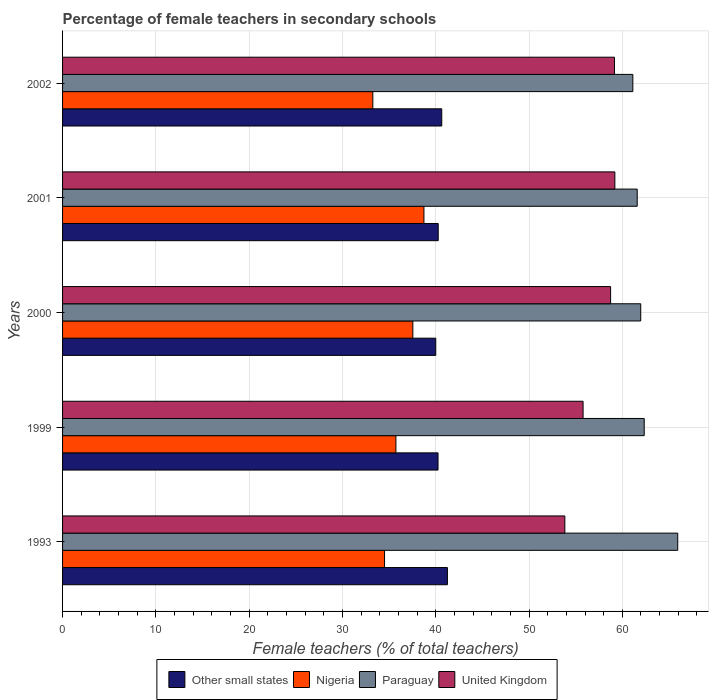How many groups of bars are there?
Keep it short and to the point. 5. Are the number of bars per tick equal to the number of legend labels?
Your answer should be compact. Yes. Are the number of bars on each tick of the Y-axis equal?
Provide a succinct answer. Yes. In how many cases, is the number of bars for a given year not equal to the number of legend labels?
Ensure brevity in your answer.  0. What is the percentage of female teachers in Other small states in 2001?
Give a very brief answer. 40.27. Across all years, what is the maximum percentage of female teachers in Other small states?
Your answer should be compact. 41.25. Across all years, what is the minimum percentage of female teachers in Paraguay?
Offer a terse response. 61.13. In which year was the percentage of female teachers in United Kingdom maximum?
Your answer should be very brief. 2001. What is the total percentage of female teachers in United Kingdom in the graph?
Offer a very short reply. 286.74. What is the difference between the percentage of female teachers in Nigeria in 1993 and that in 2000?
Keep it short and to the point. -3.03. What is the difference between the percentage of female teachers in United Kingdom in 1999 and the percentage of female teachers in Other small states in 2001?
Keep it short and to the point. 15.53. What is the average percentage of female teachers in Other small states per year?
Offer a terse response. 40.48. In the year 1999, what is the difference between the percentage of female teachers in Nigeria and percentage of female teachers in United Kingdom?
Your response must be concise. -20.06. What is the ratio of the percentage of female teachers in Nigeria in 1993 to that in 2002?
Keep it short and to the point. 1.04. What is the difference between the highest and the second highest percentage of female teachers in United Kingdom?
Make the answer very short. 0.04. What is the difference between the highest and the lowest percentage of female teachers in Other small states?
Your answer should be very brief. 1.25. In how many years, is the percentage of female teachers in Nigeria greater than the average percentage of female teachers in Nigeria taken over all years?
Keep it short and to the point. 2. Is the sum of the percentage of female teachers in United Kingdom in 1993 and 1999 greater than the maximum percentage of female teachers in Nigeria across all years?
Offer a very short reply. Yes. What does the 4th bar from the top in 1993 represents?
Keep it short and to the point. Other small states. What does the 3rd bar from the bottom in 1999 represents?
Provide a succinct answer. Paraguay. Is it the case that in every year, the sum of the percentage of female teachers in Nigeria and percentage of female teachers in Other small states is greater than the percentage of female teachers in Paraguay?
Make the answer very short. Yes. How many bars are there?
Give a very brief answer. 20. Are all the bars in the graph horizontal?
Provide a short and direct response. Yes. Are the values on the major ticks of X-axis written in scientific E-notation?
Make the answer very short. No. Does the graph contain any zero values?
Offer a terse response. No. Does the graph contain grids?
Provide a succinct answer. Yes. Where does the legend appear in the graph?
Provide a short and direct response. Bottom center. What is the title of the graph?
Your answer should be very brief. Percentage of female teachers in secondary schools. What is the label or title of the X-axis?
Your response must be concise. Female teachers (% of total teachers). What is the Female teachers (% of total teachers) in Other small states in 1993?
Your response must be concise. 41.25. What is the Female teachers (% of total teachers) of Nigeria in 1993?
Ensure brevity in your answer.  34.51. What is the Female teachers (% of total teachers) of Paraguay in 1993?
Offer a terse response. 65.94. What is the Female teachers (% of total teachers) of United Kingdom in 1993?
Give a very brief answer. 53.84. What is the Female teachers (% of total teachers) in Other small states in 1999?
Your response must be concise. 40.25. What is the Female teachers (% of total teachers) in Nigeria in 1999?
Your answer should be compact. 35.73. What is the Female teachers (% of total teachers) in Paraguay in 1999?
Make the answer very short. 62.35. What is the Female teachers (% of total teachers) in United Kingdom in 1999?
Provide a short and direct response. 55.79. What is the Female teachers (% of total teachers) in Other small states in 2000?
Your answer should be very brief. 40. What is the Female teachers (% of total teachers) of Nigeria in 2000?
Make the answer very short. 37.55. What is the Female teachers (% of total teachers) in Paraguay in 2000?
Make the answer very short. 61.97. What is the Female teachers (% of total teachers) of United Kingdom in 2000?
Provide a succinct answer. 58.75. What is the Female teachers (% of total teachers) in Other small states in 2001?
Your answer should be compact. 40.27. What is the Female teachers (% of total teachers) of Nigeria in 2001?
Your answer should be compact. 38.74. What is the Female teachers (% of total teachers) in Paraguay in 2001?
Provide a short and direct response. 61.6. What is the Female teachers (% of total teachers) of United Kingdom in 2001?
Provide a succinct answer. 59.2. What is the Female teachers (% of total teachers) of Other small states in 2002?
Ensure brevity in your answer.  40.65. What is the Female teachers (% of total teachers) of Nigeria in 2002?
Offer a very short reply. 33.26. What is the Female teachers (% of total teachers) of Paraguay in 2002?
Keep it short and to the point. 61.13. What is the Female teachers (% of total teachers) in United Kingdom in 2002?
Your response must be concise. 59.16. Across all years, what is the maximum Female teachers (% of total teachers) of Other small states?
Offer a terse response. 41.25. Across all years, what is the maximum Female teachers (% of total teachers) in Nigeria?
Your answer should be compact. 38.74. Across all years, what is the maximum Female teachers (% of total teachers) in Paraguay?
Your answer should be very brief. 65.94. Across all years, what is the maximum Female teachers (% of total teachers) in United Kingdom?
Make the answer very short. 59.2. Across all years, what is the minimum Female teachers (% of total teachers) of Other small states?
Offer a very short reply. 40. Across all years, what is the minimum Female teachers (% of total teachers) in Nigeria?
Provide a short and direct response. 33.26. Across all years, what is the minimum Female teachers (% of total teachers) of Paraguay?
Give a very brief answer. 61.13. Across all years, what is the minimum Female teachers (% of total teachers) of United Kingdom?
Offer a very short reply. 53.84. What is the total Female teachers (% of total teachers) of Other small states in the graph?
Offer a very short reply. 202.41. What is the total Female teachers (% of total teachers) in Nigeria in the graph?
Provide a succinct answer. 179.78. What is the total Female teachers (% of total teachers) in Paraguay in the graph?
Ensure brevity in your answer.  312.99. What is the total Female teachers (% of total teachers) of United Kingdom in the graph?
Your response must be concise. 286.74. What is the difference between the Female teachers (% of total teachers) in Other small states in 1993 and that in 1999?
Provide a succinct answer. 1.01. What is the difference between the Female teachers (% of total teachers) of Nigeria in 1993 and that in 1999?
Your answer should be very brief. -1.22. What is the difference between the Female teachers (% of total teachers) of Paraguay in 1993 and that in 1999?
Your answer should be compact. 3.59. What is the difference between the Female teachers (% of total teachers) in United Kingdom in 1993 and that in 1999?
Offer a terse response. -1.95. What is the difference between the Female teachers (% of total teachers) of Other small states in 1993 and that in 2000?
Provide a succinct answer. 1.25. What is the difference between the Female teachers (% of total teachers) of Nigeria in 1993 and that in 2000?
Offer a terse response. -3.03. What is the difference between the Female teachers (% of total teachers) in Paraguay in 1993 and that in 2000?
Your answer should be compact. 3.97. What is the difference between the Female teachers (% of total teachers) of United Kingdom in 1993 and that in 2000?
Provide a succinct answer. -4.91. What is the difference between the Female teachers (% of total teachers) of Other small states in 1993 and that in 2001?
Provide a short and direct response. 0.99. What is the difference between the Female teachers (% of total teachers) of Nigeria in 1993 and that in 2001?
Provide a succinct answer. -4.22. What is the difference between the Female teachers (% of total teachers) in Paraguay in 1993 and that in 2001?
Provide a succinct answer. 4.34. What is the difference between the Female teachers (% of total teachers) of United Kingdom in 1993 and that in 2001?
Offer a very short reply. -5.36. What is the difference between the Female teachers (% of total teachers) in Other small states in 1993 and that in 2002?
Ensure brevity in your answer.  0.61. What is the difference between the Female teachers (% of total teachers) in Nigeria in 1993 and that in 2002?
Make the answer very short. 1.26. What is the difference between the Female teachers (% of total teachers) in Paraguay in 1993 and that in 2002?
Give a very brief answer. 4.81. What is the difference between the Female teachers (% of total teachers) in United Kingdom in 1993 and that in 2002?
Make the answer very short. -5.32. What is the difference between the Female teachers (% of total teachers) in Other small states in 1999 and that in 2000?
Provide a short and direct response. 0.24. What is the difference between the Female teachers (% of total teachers) in Nigeria in 1999 and that in 2000?
Your answer should be compact. -1.81. What is the difference between the Female teachers (% of total teachers) of Paraguay in 1999 and that in 2000?
Your answer should be very brief. 0.37. What is the difference between the Female teachers (% of total teachers) of United Kingdom in 1999 and that in 2000?
Keep it short and to the point. -2.95. What is the difference between the Female teachers (% of total teachers) in Other small states in 1999 and that in 2001?
Give a very brief answer. -0.02. What is the difference between the Female teachers (% of total teachers) of Nigeria in 1999 and that in 2001?
Offer a terse response. -3. What is the difference between the Female teachers (% of total teachers) of Paraguay in 1999 and that in 2001?
Offer a terse response. 0.75. What is the difference between the Female teachers (% of total teachers) in United Kingdom in 1999 and that in 2001?
Provide a short and direct response. -3.41. What is the difference between the Female teachers (% of total teachers) in Other small states in 1999 and that in 2002?
Offer a very short reply. -0.4. What is the difference between the Female teachers (% of total teachers) in Nigeria in 1999 and that in 2002?
Your answer should be compact. 2.48. What is the difference between the Female teachers (% of total teachers) in Paraguay in 1999 and that in 2002?
Provide a succinct answer. 1.22. What is the difference between the Female teachers (% of total teachers) of United Kingdom in 1999 and that in 2002?
Make the answer very short. -3.37. What is the difference between the Female teachers (% of total teachers) in Other small states in 2000 and that in 2001?
Offer a terse response. -0.26. What is the difference between the Female teachers (% of total teachers) of Nigeria in 2000 and that in 2001?
Your answer should be compact. -1.19. What is the difference between the Female teachers (% of total teachers) in Paraguay in 2000 and that in 2001?
Your answer should be very brief. 0.38. What is the difference between the Female teachers (% of total teachers) in United Kingdom in 2000 and that in 2001?
Your response must be concise. -0.45. What is the difference between the Female teachers (% of total teachers) in Other small states in 2000 and that in 2002?
Give a very brief answer. -0.64. What is the difference between the Female teachers (% of total teachers) in Nigeria in 2000 and that in 2002?
Keep it short and to the point. 4.29. What is the difference between the Female teachers (% of total teachers) in Paraguay in 2000 and that in 2002?
Give a very brief answer. 0.84. What is the difference between the Female teachers (% of total teachers) of United Kingdom in 2000 and that in 2002?
Keep it short and to the point. -0.41. What is the difference between the Female teachers (% of total teachers) in Other small states in 2001 and that in 2002?
Give a very brief answer. -0.38. What is the difference between the Female teachers (% of total teachers) in Nigeria in 2001 and that in 2002?
Make the answer very short. 5.48. What is the difference between the Female teachers (% of total teachers) in Paraguay in 2001 and that in 2002?
Make the answer very short. 0.47. What is the difference between the Female teachers (% of total teachers) of United Kingdom in 2001 and that in 2002?
Make the answer very short. 0.04. What is the difference between the Female teachers (% of total teachers) in Other small states in 1993 and the Female teachers (% of total teachers) in Nigeria in 1999?
Your answer should be very brief. 5.52. What is the difference between the Female teachers (% of total teachers) in Other small states in 1993 and the Female teachers (% of total teachers) in Paraguay in 1999?
Keep it short and to the point. -21.1. What is the difference between the Female teachers (% of total teachers) of Other small states in 1993 and the Female teachers (% of total teachers) of United Kingdom in 1999?
Your answer should be very brief. -14.54. What is the difference between the Female teachers (% of total teachers) of Nigeria in 1993 and the Female teachers (% of total teachers) of Paraguay in 1999?
Offer a terse response. -27.84. What is the difference between the Female teachers (% of total teachers) of Nigeria in 1993 and the Female teachers (% of total teachers) of United Kingdom in 1999?
Your answer should be compact. -21.28. What is the difference between the Female teachers (% of total teachers) in Paraguay in 1993 and the Female teachers (% of total teachers) in United Kingdom in 1999?
Your answer should be very brief. 10.15. What is the difference between the Female teachers (% of total teachers) of Other small states in 1993 and the Female teachers (% of total teachers) of Nigeria in 2000?
Offer a very short reply. 3.7. What is the difference between the Female teachers (% of total teachers) in Other small states in 1993 and the Female teachers (% of total teachers) in Paraguay in 2000?
Make the answer very short. -20.72. What is the difference between the Female teachers (% of total teachers) of Other small states in 1993 and the Female teachers (% of total teachers) of United Kingdom in 2000?
Make the answer very short. -17.49. What is the difference between the Female teachers (% of total teachers) of Nigeria in 1993 and the Female teachers (% of total teachers) of Paraguay in 2000?
Give a very brief answer. -27.46. What is the difference between the Female teachers (% of total teachers) in Nigeria in 1993 and the Female teachers (% of total teachers) in United Kingdom in 2000?
Your answer should be compact. -24.23. What is the difference between the Female teachers (% of total teachers) in Paraguay in 1993 and the Female teachers (% of total teachers) in United Kingdom in 2000?
Provide a succinct answer. 7.2. What is the difference between the Female teachers (% of total teachers) in Other small states in 1993 and the Female teachers (% of total teachers) in Nigeria in 2001?
Keep it short and to the point. 2.52. What is the difference between the Female teachers (% of total teachers) in Other small states in 1993 and the Female teachers (% of total teachers) in Paraguay in 2001?
Your response must be concise. -20.35. What is the difference between the Female teachers (% of total teachers) of Other small states in 1993 and the Female teachers (% of total teachers) of United Kingdom in 2001?
Your response must be concise. -17.95. What is the difference between the Female teachers (% of total teachers) in Nigeria in 1993 and the Female teachers (% of total teachers) in Paraguay in 2001?
Your response must be concise. -27.09. What is the difference between the Female teachers (% of total teachers) in Nigeria in 1993 and the Female teachers (% of total teachers) in United Kingdom in 2001?
Give a very brief answer. -24.69. What is the difference between the Female teachers (% of total teachers) of Paraguay in 1993 and the Female teachers (% of total teachers) of United Kingdom in 2001?
Offer a terse response. 6.74. What is the difference between the Female teachers (% of total teachers) of Other small states in 1993 and the Female teachers (% of total teachers) of Nigeria in 2002?
Offer a very short reply. 7.99. What is the difference between the Female teachers (% of total teachers) of Other small states in 1993 and the Female teachers (% of total teachers) of Paraguay in 2002?
Offer a terse response. -19.88. What is the difference between the Female teachers (% of total teachers) in Other small states in 1993 and the Female teachers (% of total teachers) in United Kingdom in 2002?
Your response must be concise. -17.91. What is the difference between the Female teachers (% of total teachers) of Nigeria in 1993 and the Female teachers (% of total teachers) of Paraguay in 2002?
Ensure brevity in your answer.  -26.62. What is the difference between the Female teachers (% of total teachers) in Nigeria in 1993 and the Female teachers (% of total teachers) in United Kingdom in 2002?
Your answer should be compact. -24.65. What is the difference between the Female teachers (% of total teachers) of Paraguay in 1993 and the Female teachers (% of total teachers) of United Kingdom in 2002?
Provide a short and direct response. 6.78. What is the difference between the Female teachers (% of total teachers) in Other small states in 1999 and the Female teachers (% of total teachers) in Nigeria in 2000?
Offer a terse response. 2.7. What is the difference between the Female teachers (% of total teachers) of Other small states in 1999 and the Female teachers (% of total teachers) of Paraguay in 2000?
Make the answer very short. -21.73. What is the difference between the Female teachers (% of total teachers) in Other small states in 1999 and the Female teachers (% of total teachers) in United Kingdom in 2000?
Your response must be concise. -18.5. What is the difference between the Female teachers (% of total teachers) of Nigeria in 1999 and the Female teachers (% of total teachers) of Paraguay in 2000?
Keep it short and to the point. -26.24. What is the difference between the Female teachers (% of total teachers) in Nigeria in 1999 and the Female teachers (% of total teachers) in United Kingdom in 2000?
Offer a terse response. -23.01. What is the difference between the Female teachers (% of total teachers) in Paraguay in 1999 and the Female teachers (% of total teachers) in United Kingdom in 2000?
Offer a terse response. 3.6. What is the difference between the Female teachers (% of total teachers) in Other small states in 1999 and the Female teachers (% of total teachers) in Nigeria in 2001?
Your response must be concise. 1.51. What is the difference between the Female teachers (% of total teachers) in Other small states in 1999 and the Female teachers (% of total teachers) in Paraguay in 2001?
Make the answer very short. -21.35. What is the difference between the Female teachers (% of total teachers) in Other small states in 1999 and the Female teachers (% of total teachers) in United Kingdom in 2001?
Give a very brief answer. -18.95. What is the difference between the Female teachers (% of total teachers) in Nigeria in 1999 and the Female teachers (% of total teachers) in Paraguay in 2001?
Provide a succinct answer. -25.86. What is the difference between the Female teachers (% of total teachers) of Nigeria in 1999 and the Female teachers (% of total teachers) of United Kingdom in 2001?
Your answer should be very brief. -23.47. What is the difference between the Female teachers (% of total teachers) in Paraguay in 1999 and the Female teachers (% of total teachers) in United Kingdom in 2001?
Make the answer very short. 3.15. What is the difference between the Female teachers (% of total teachers) of Other small states in 1999 and the Female teachers (% of total teachers) of Nigeria in 2002?
Your answer should be very brief. 6.99. What is the difference between the Female teachers (% of total teachers) of Other small states in 1999 and the Female teachers (% of total teachers) of Paraguay in 2002?
Provide a short and direct response. -20.88. What is the difference between the Female teachers (% of total teachers) of Other small states in 1999 and the Female teachers (% of total teachers) of United Kingdom in 2002?
Ensure brevity in your answer.  -18.91. What is the difference between the Female teachers (% of total teachers) of Nigeria in 1999 and the Female teachers (% of total teachers) of Paraguay in 2002?
Keep it short and to the point. -25.4. What is the difference between the Female teachers (% of total teachers) of Nigeria in 1999 and the Female teachers (% of total teachers) of United Kingdom in 2002?
Provide a succinct answer. -23.43. What is the difference between the Female teachers (% of total teachers) of Paraguay in 1999 and the Female teachers (% of total teachers) of United Kingdom in 2002?
Keep it short and to the point. 3.19. What is the difference between the Female teachers (% of total teachers) of Other small states in 2000 and the Female teachers (% of total teachers) of Nigeria in 2001?
Keep it short and to the point. 1.27. What is the difference between the Female teachers (% of total teachers) of Other small states in 2000 and the Female teachers (% of total teachers) of Paraguay in 2001?
Your response must be concise. -21.59. What is the difference between the Female teachers (% of total teachers) in Other small states in 2000 and the Female teachers (% of total teachers) in United Kingdom in 2001?
Your answer should be very brief. -19.2. What is the difference between the Female teachers (% of total teachers) of Nigeria in 2000 and the Female teachers (% of total teachers) of Paraguay in 2001?
Your answer should be very brief. -24.05. What is the difference between the Female teachers (% of total teachers) in Nigeria in 2000 and the Female teachers (% of total teachers) in United Kingdom in 2001?
Offer a very short reply. -21.65. What is the difference between the Female teachers (% of total teachers) in Paraguay in 2000 and the Female teachers (% of total teachers) in United Kingdom in 2001?
Keep it short and to the point. 2.77. What is the difference between the Female teachers (% of total teachers) of Other small states in 2000 and the Female teachers (% of total teachers) of Nigeria in 2002?
Provide a short and direct response. 6.75. What is the difference between the Female teachers (% of total teachers) of Other small states in 2000 and the Female teachers (% of total teachers) of Paraguay in 2002?
Your answer should be very brief. -21.12. What is the difference between the Female teachers (% of total teachers) of Other small states in 2000 and the Female teachers (% of total teachers) of United Kingdom in 2002?
Your answer should be compact. -19.16. What is the difference between the Female teachers (% of total teachers) in Nigeria in 2000 and the Female teachers (% of total teachers) in Paraguay in 2002?
Provide a succinct answer. -23.58. What is the difference between the Female teachers (% of total teachers) in Nigeria in 2000 and the Female teachers (% of total teachers) in United Kingdom in 2002?
Keep it short and to the point. -21.61. What is the difference between the Female teachers (% of total teachers) in Paraguay in 2000 and the Female teachers (% of total teachers) in United Kingdom in 2002?
Keep it short and to the point. 2.81. What is the difference between the Female teachers (% of total teachers) in Other small states in 2001 and the Female teachers (% of total teachers) in Nigeria in 2002?
Your answer should be compact. 7.01. What is the difference between the Female teachers (% of total teachers) in Other small states in 2001 and the Female teachers (% of total teachers) in Paraguay in 2002?
Keep it short and to the point. -20.86. What is the difference between the Female teachers (% of total teachers) of Other small states in 2001 and the Female teachers (% of total teachers) of United Kingdom in 2002?
Keep it short and to the point. -18.89. What is the difference between the Female teachers (% of total teachers) of Nigeria in 2001 and the Female teachers (% of total teachers) of Paraguay in 2002?
Offer a terse response. -22.39. What is the difference between the Female teachers (% of total teachers) of Nigeria in 2001 and the Female teachers (% of total teachers) of United Kingdom in 2002?
Provide a short and direct response. -20.42. What is the difference between the Female teachers (% of total teachers) of Paraguay in 2001 and the Female teachers (% of total teachers) of United Kingdom in 2002?
Ensure brevity in your answer.  2.44. What is the average Female teachers (% of total teachers) in Other small states per year?
Make the answer very short. 40.48. What is the average Female teachers (% of total teachers) in Nigeria per year?
Give a very brief answer. 35.96. What is the average Female teachers (% of total teachers) of Paraguay per year?
Offer a very short reply. 62.6. What is the average Female teachers (% of total teachers) of United Kingdom per year?
Offer a very short reply. 57.35. In the year 1993, what is the difference between the Female teachers (% of total teachers) in Other small states and Female teachers (% of total teachers) in Nigeria?
Give a very brief answer. 6.74. In the year 1993, what is the difference between the Female teachers (% of total teachers) of Other small states and Female teachers (% of total teachers) of Paraguay?
Give a very brief answer. -24.69. In the year 1993, what is the difference between the Female teachers (% of total teachers) in Other small states and Female teachers (% of total teachers) in United Kingdom?
Ensure brevity in your answer.  -12.59. In the year 1993, what is the difference between the Female teachers (% of total teachers) in Nigeria and Female teachers (% of total teachers) in Paraguay?
Offer a very short reply. -31.43. In the year 1993, what is the difference between the Female teachers (% of total teachers) in Nigeria and Female teachers (% of total teachers) in United Kingdom?
Your answer should be very brief. -19.33. In the year 1993, what is the difference between the Female teachers (% of total teachers) in Paraguay and Female teachers (% of total teachers) in United Kingdom?
Offer a very short reply. 12.1. In the year 1999, what is the difference between the Female teachers (% of total teachers) in Other small states and Female teachers (% of total teachers) in Nigeria?
Give a very brief answer. 4.51. In the year 1999, what is the difference between the Female teachers (% of total teachers) of Other small states and Female teachers (% of total teachers) of Paraguay?
Offer a very short reply. -22.1. In the year 1999, what is the difference between the Female teachers (% of total teachers) in Other small states and Female teachers (% of total teachers) in United Kingdom?
Your answer should be very brief. -15.55. In the year 1999, what is the difference between the Female teachers (% of total teachers) of Nigeria and Female teachers (% of total teachers) of Paraguay?
Your answer should be very brief. -26.62. In the year 1999, what is the difference between the Female teachers (% of total teachers) of Nigeria and Female teachers (% of total teachers) of United Kingdom?
Offer a very short reply. -20.06. In the year 1999, what is the difference between the Female teachers (% of total teachers) of Paraguay and Female teachers (% of total teachers) of United Kingdom?
Offer a terse response. 6.55. In the year 2000, what is the difference between the Female teachers (% of total teachers) in Other small states and Female teachers (% of total teachers) in Nigeria?
Your answer should be very brief. 2.46. In the year 2000, what is the difference between the Female teachers (% of total teachers) of Other small states and Female teachers (% of total teachers) of Paraguay?
Offer a terse response. -21.97. In the year 2000, what is the difference between the Female teachers (% of total teachers) of Other small states and Female teachers (% of total teachers) of United Kingdom?
Keep it short and to the point. -18.74. In the year 2000, what is the difference between the Female teachers (% of total teachers) of Nigeria and Female teachers (% of total teachers) of Paraguay?
Offer a very short reply. -24.43. In the year 2000, what is the difference between the Female teachers (% of total teachers) of Nigeria and Female teachers (% of total teachers) of United Kingdom?
Offer a terse response. -21.2. In the year 2000, what is the difference between the Female teachers (% of total teachers) in Paraguay and Female teachers (% of total teachers) in United Kingdom?
Make the answer very short. 3.23. In the year 2001, what is the difference between the Female teachers (% of total teachers) of Other small states and Female teachers (% of total teachers) of Nigeria?
Your response must be concise. 1.53. In the year 2001, what is the difference between the Female teachers (% of total teachers) of Other small states and Female teachers (% of total teachers) of Paraguay?
Ensure brevity in your answer.  -21.33. In the year 2001, what is the difference between the Female teachers (% of total teachers) in Other small states and Female teachers (% of total teachers) in United Kingdom?
Provide a succinct answer. -18.93. In the year 2001, what is the difference between the Female teachers (% of total teachers) in Nigeria and Female teachers (% of total teachers) in Paraguay?
Your answer should be very brief. -22.86. In the year 2001, what is the difference between the Female teachers (% of total teachers) in Nigeria and Female teachers (% of total teachers) in United Kingdom?
Ensure brevity in your answer.  -20.46. In the year 2001, what is the difference between the Female teachers (% of total teachers) in Paraguay and Female teachers (% of total teachers) in United Kingdom?
Make the answer very short. 2.4. In the year 2002, what is the difference between the Female teachers (% of total teachers) of Other small states and Female teachers (% of total teachers) of Nigeria?
Keep it short and to the point. 7.39. In the year 2002, what is the difference between the Female teachers (% of total teachers) in Other small states and Female teachers (% of total teachers) in Paraguay?
Ensure brevity in your answer.  -20.48. In the year 2002, what is the difference between the Female teachers (% of total teachers) of Other small states and Female teachers (% of total teachers) of United Kingdom?
Make the answer very short. -18.51. In the year 2002, what is the difference between the Female teachers (% of total teachers) of Nigeria and Female teachers (% of total teachers) of Paraguay?
Give a very brief answer. -27.87. In the year 2002, what is the difference between the Female teachers (% of total teachers) in Nigeria and Female teachers (% of total teachers) in United Kingdom?
Your answer should be very brief. -25.9. In the year 2002, what is the difference between the Female teachers (% of total teachers) in Paraguay and Female teachers (% of total teachers) in United Kingdom?
Your response must be concise. 1.97. What is the ratio of the Female teachers (% of total teachers) of Other small states in 1993 to that in 1999?
Your answer should be very brief. 1.02. What is the ratio of the Female teachers (% of total teachers) of Nigeria in 1993 to that in 1999?
Provide a short and direct response. 0.97. What is the ratio of the Female teachers (% of total teachers) of Paraguay in 1993 to that in 1999?
Your answer should be compact. 1.06. What is the ratio of the Female teachers (% of total teachers) in United Kingdom in 1993 to that in 1999?
Your answer should be very brief. 0.96. What is the ratio of the Female teachers (% of total teachers) in Other small states in 1993 to that in 2000?
Your answer should be very brief. 1.03. What is the ratio of the Female teachers (% of total teachers) of Nigeria in 1993 to that in 2000?
Offer a very short reply. 0.92. What is the ratio of the Female teachers (% of total teachers) in Paraguay in 1993 to that in 2000?
Your answer should be compact. 1.06. What is the ratio of the Female teachers (% of total teachers) in United Kingdom in 1993 to that in 2000?
Provide a succinct answer. 0.92. What is the ratio of the Female teachers (% of total teachers) of Other small states in 1993 to that in 2001?
Provide a succinct answer. 1.02. What is the ratio of the Female teachers (% of total teachers) of Nigeria in 1993 to that in 2001?
Provide a succinct answer. 0.89. What is the ratio of the Female teachers (% of total teachers) of Paraguay in 1993 to that in 2001?
Provide a short and direct response. 1.07. What is the ratio of the Female teachers (% of total teachers) of United Kingdom in 1993 to that in 2001?
Offer a very short reply. 0.91. What is the ratio of the Female teachers (% of total teachers) in Other small states in 1993 to that in 2002?
Keep it short and to the point. 1.01. What is the ratio of the Female teachers (% of total teachers) in Nigeria in 1993 to that in 2002?
Your answer should be compact. 1.04. What is the ratio of the Female teachers (% of total teachers) of Paraguay in 1993 to that in 2002?
Give a very brief answer. 1.08. What is the ratio of the Female teachers (% of total teachers) of United Kingdom in 1993 to that in 2002?
Make the answer very short. 0.91. What is the ratio of the Female teachers (% of total teachers) in Other small states in 1999 to that in 2000?
Offer a terse response. 1.01. What is the ratio of the Female teachers (% of total teachers) of Nigeria in 1999 to that in 2000?
Offer a terse response. 0.95. What is the ratio of the Female teachers (% of total teachers) in Paraguay in 1999 to that in 2000?
Keep it short and to the point. 1.01. What is the ratio of the Female teachers (% of total teachers) in United Kingdom in 1999 to that in 2000?
Provide a succinct answer. 0.95. What is the ratio of the Female teachers (% of total teachers) of Nigeria in 1999 to that in 2001?
Ensure brevity in your answer.  0.92. What is the ratio of the Female teachers (% of total teachers) of Paraguay in 1999 to that in 2001?
Ensure brevity in your answer.  1.01. What is the ratio of the Female teachers (% of total teachers) in United Kingdom in 1999 to that in 2001?
Keep it short and to the point. 0.94. What is the ratio of the Female teachers (% of total teachers) in Other small states in 1999 to that in 2002?
Make the answer very short. 0.99. What is the ratio of the Female teachers (% of total teachers) of Nigeria in 1999 to that in 2002?
Your answer should be compact. 1.07. What is the ratio of the Female teachers (% of total teachers) in Paraguay in 1999 to that in 2002?
Offer a terse response. 1.02. What is the ratio of the Female teachers (% of total teachers) of United Kingdom in 1999 to that in 2002?
Provide a short and direct response. 0.94. What is the ratio of the Female teachers (% of total teachers) in Nigeria in 2000 to that in 2001?
Make the answer very short. 0.97. What is the ratio of the Female teachers (% of total teachers) of Paraguay in 2000 to that in 2001?
Your answer should be very brief. 1.01. What is the ratio of the Female teachers (% of total teachers) of Other small states in 2000 to that in 2002?
Ensure brevity in your answer.  0.98. What is the ratio of the Female teachers (% of total teachers) of Nigeria in 2000 to that in 2002?
Provide a succinct answer. 1.13. What is the ratio of the Female teachers (% of total teachers) in Paraguay in 2000 to that in 2002?
Offer a very short reply. 1.01. What is the ratio of the Female teachers (% of total teachers) of Nigeria in 2001 to that in 2002?
Your answer should be very brief. 1.16. What is the ratio of the Female teachers (% of total teachers) in Paraguay in 2001 to that in 2002?
Give a very brief answer. 1.01. What is the ratio of the Female teachers (% of total teachers) in United Kingdom in 2001 to that in 2002?
Your answer should be compact. 1. What is the difference between the highest and the second highest Female teachers (% of total teachers) of Other small states?
Provide a short and direct response. 0.61. What is the difference between the highest and the second highest Female teachers (% of total teachers) of Nigeria?
Provide a short and direct response. 1.19. What is the difference between the highest and the second highest Female teachers (% of total teachers) of Paraguay?
Provide a short and direct response. 3.59. What is the difference between the highest and the second highest Female teachers (% of total teachers) in United Kingdom?
Provide a succinct answer. 0.04. What is the difference between the highest and the lowest Female teachers (% of total teachers) of Other small states?
Your answer should be very brief. 1.25. What is the difference between the highest and the lowest Female teachers (% of total teachers) in Nigeria?
Provide a succinct answer. 5.48. What is the difference between the highest and the lowest Female teachers (% of total teachers) in Paraguay?
Offer a terse response. 4.81. What is the difference between the highest and the lowest Female teachers (% of total teachers) of United Kingdom?
Your response must be concise. 5.36. 